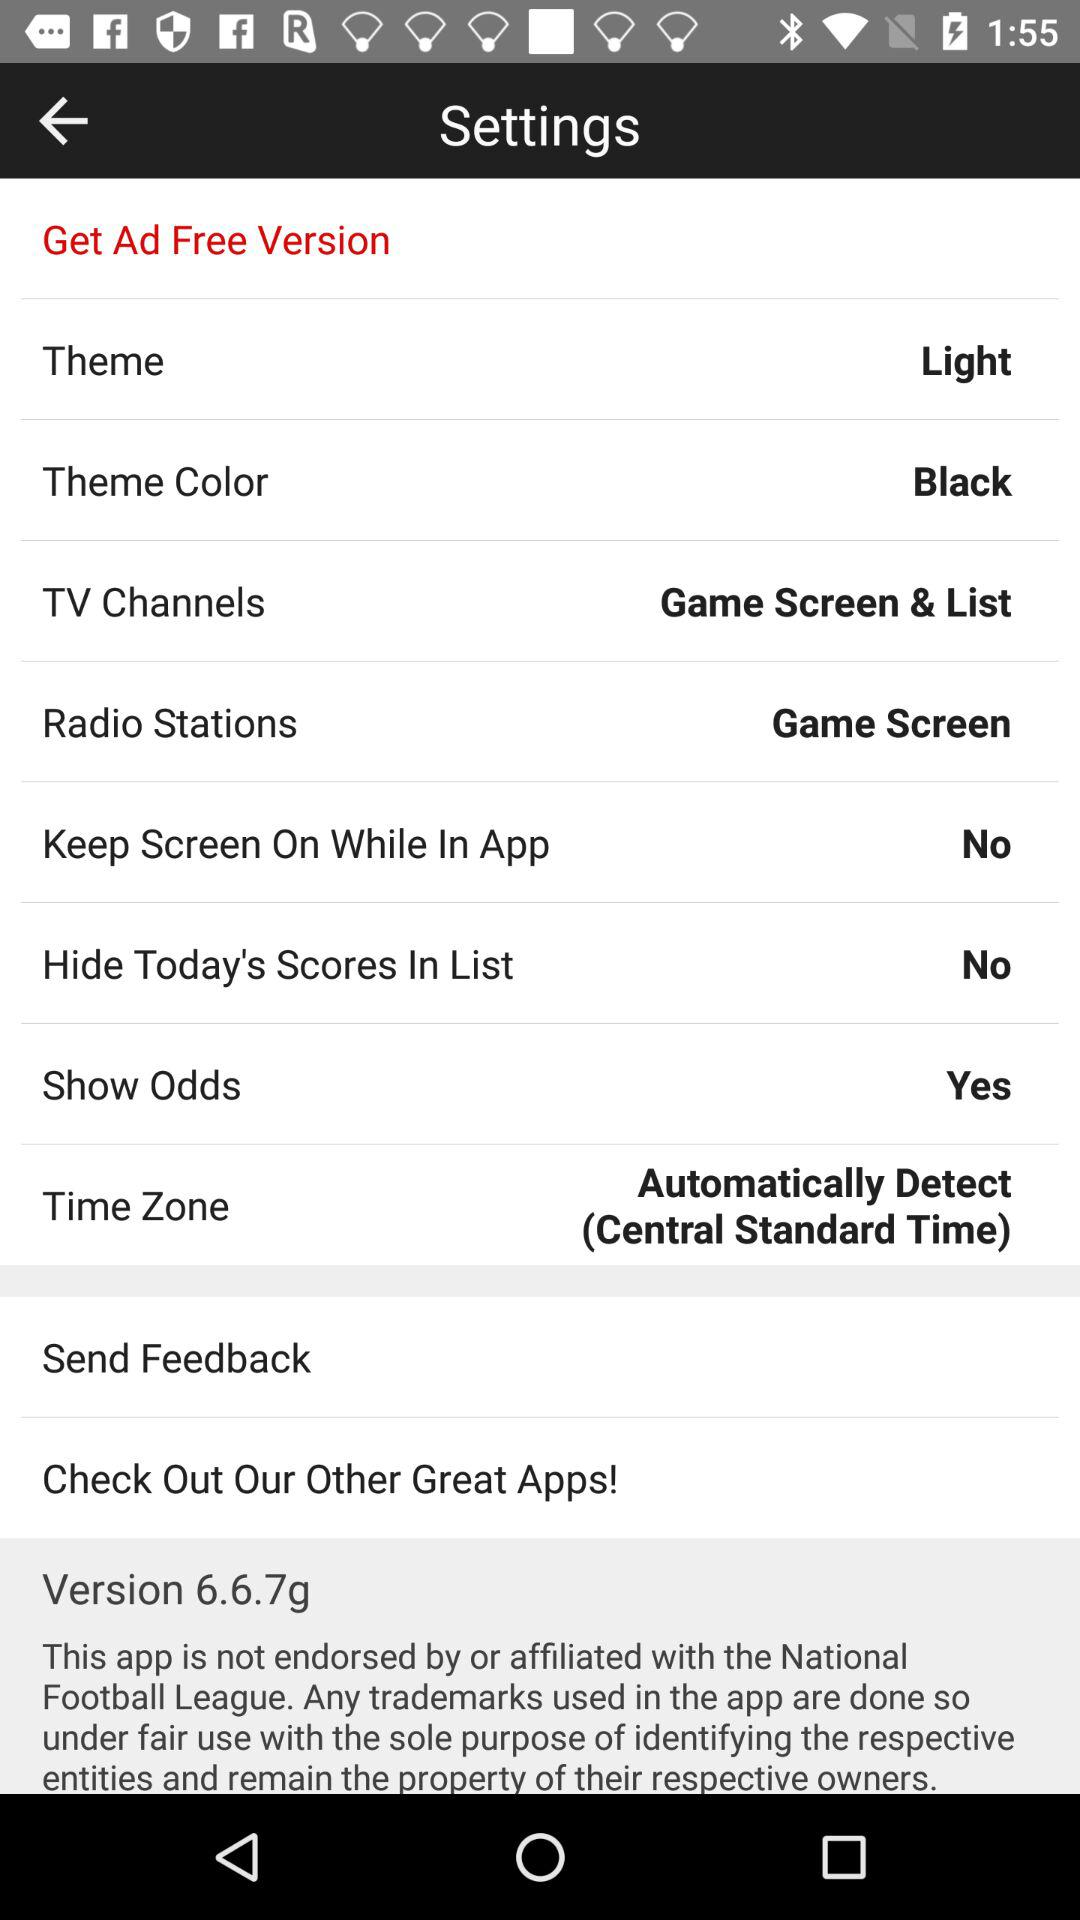What is the radio station? The radio station is "Game Screen". 